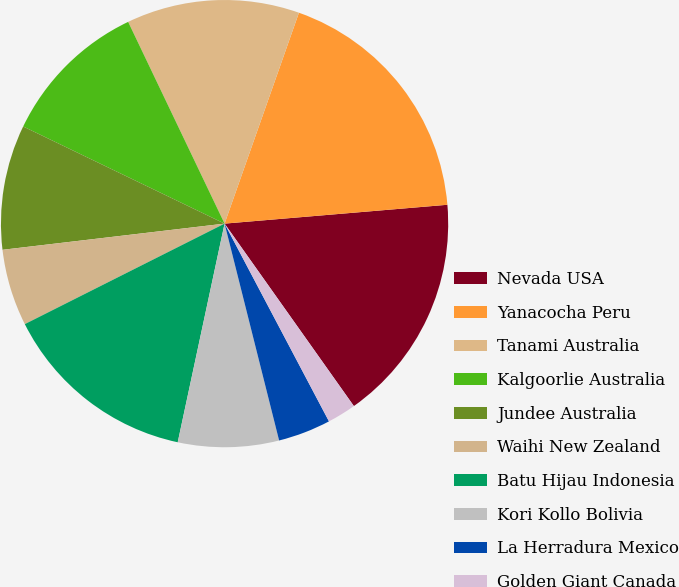Convert chart. <chart><loc_0><loc_0><loc_500><loc_500><pie_chart><fcel>Nevada USA<fcel>Yanacocha Peru<fcel>Tanami Australia<fcel>Kalgoorlie Australia<fcel>Jundee Australia<fcel>Waihi New Zealand<fcel>Batu Hijau Indonesia<fcel>Kori Kollo Bolivia<fcel>La Herradura Mexico<fcel>Golden Giant Canada<nl><fcel>16.53%<fcel>18.26%<fcel>12.49%<fcel>10.75%<fcel>9.02%<fcel>5.55%<fcel>14.22%<fcel>7.28%<fcel>3.81%<fcel>2.08%<nl></chart> 